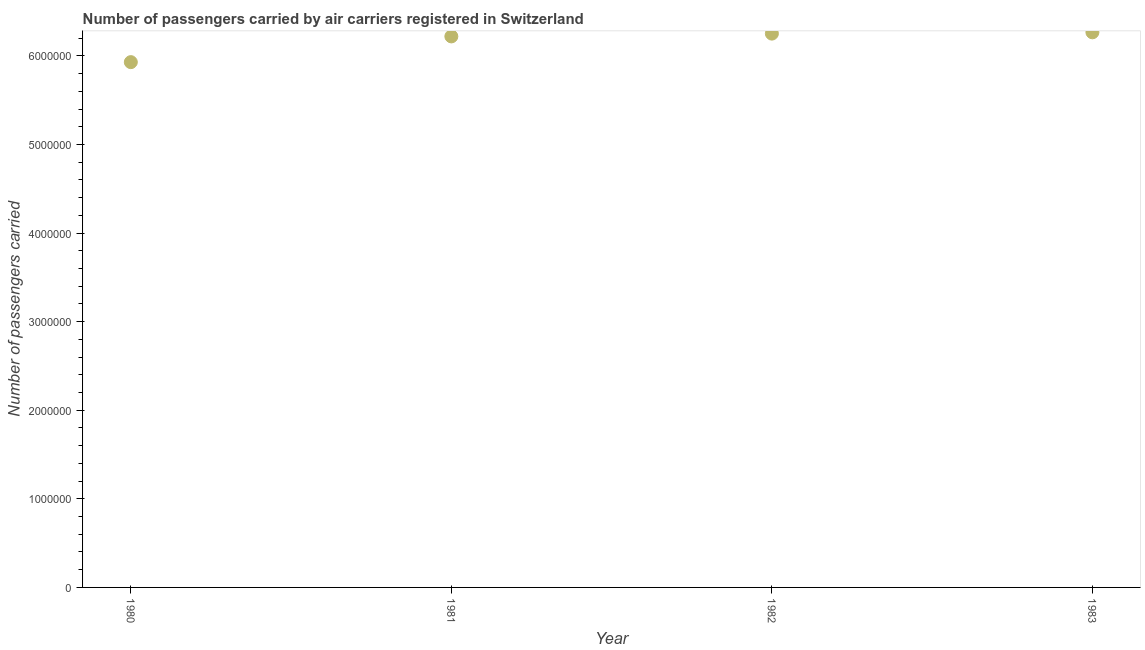What is the number of passengers carried in 1980?
Offer a terse response. 5.93e+06. Across all years, what is the maximum number of passengers carried?
Your response must be concise. 6.27e+06. Across all years, what is the minimum number of passengers carried?
Keep it short and to the point. 5.93e+06. In which year was the number of passengers carried minimum?
Offer a terse response. 1980. What is the sum of the number of passengers carried?
Make the answer very short. 2.47e+07. What is the difference between the number of passengers carried in 1981 and 1983?
Provide a succinct answer. -4.62e+04. What is the average number of passengers carried per year?
Ensure brevity in your answer.  6.17e+06. What is the median number of passengers carried?
Your response must be concise. 6.24e+06. In how many years, is the number of passengers carried greater than 1800000 ?
Give a very brief answer. 4. Do a majority of the years between 1982 and 1983 (inclusive) have number of passengers carried greater than 5000000 ?
Offer a terse response. Yes. What is the ratio of the number of passengers carried in 1981 to that in 1983?
Your answer should be compact. 0.99. Is the number of passengers carried in 1980 less than that in 1982?
Ensure brevity in your answer.  Yes. What is the difference between the highest and the second highest number of passengers carried?
Offer a very short reply. 1.46e+04. Is the sum of the number of passengers carried in 1981 and 1983 greater than the maximum number of passengers carried across all years?
Keep it short and to the point. Yes. What is the difference between the highest and the lowest number of passengers carried?
Your answer should be very brief. 3.37e+05. Does the number of passengers carried monotonically increase over the years?
Offer a terse response. Yes. What is the difference between two consecutive major ticks on the Y-axis?
Provide a succinct answer. 1.00e+06. Are the values on the major ticks of Y-axis written in scientific E-notation?
Provide a short and direct response. No. Does the graph contain any zero values?
Give a very brief answer. No. Does the graph contain grids?
Give a very brief answer. No. What is the title of the graph?
Provide a short and direct response. Number of passengers carried by air carriers registered in Switzerland. What is the label or title of the X-axis?
Provide a succinct answer. Year. What is the label or title of the Y-axis?
Your answer should be very brief. Number of passengers carried. What is the Number of passengers carried in 1980?
Offer a very short reply. 5.93e+06. What is the Number of passengers carried in 1981?
Your answer should be very brief. 6.22e+06. What is the Number of passengers carried in 1982?
Your answer should be very brief. 6.25e+06. What is the Number of passengers carried in 1983?
Ensure brevity in your answer.  6.27e+06. What is the difference between the Number of passengers carried in 1980 and 1981?
Your answer should be very brief. -2.90e+05. What is the difference between the Number of passengers carried in 1980 and 1982?
Make the answer very short. -3.22e+05. What is the difference between the Number of passengers carried in 1980 and 1983?
Your answer should be compact. -3.37e+05. What is the difference between the Number of passengers carried in 1981 and 1982?
Provide a short and direct response. -3.16e+04. What is the difference between the Number of passengers carried in 1981 and 1983?
Your answer should be very brief. -4.62e+04. What is the difference between the Number of passengers carried in 1982 and 1983?
Your answer should be compact. -1.46e+04. What is the ratio of the Number of passengers carried in 1980 to that in 1981?
Keep it short and to the point. 0.95. What is the ratio of the Number of passengers carried in 1980 to that in 1982?
Your answer should be very brief. 0.95. What is the ratio of the Number of passengers carried in 1980 to that in 1983?
Offer a very short reply. 0.95. What is the ratio of the Number of passengers carried in 1982 to that in 1983?
Your answer should be compact. 1. 